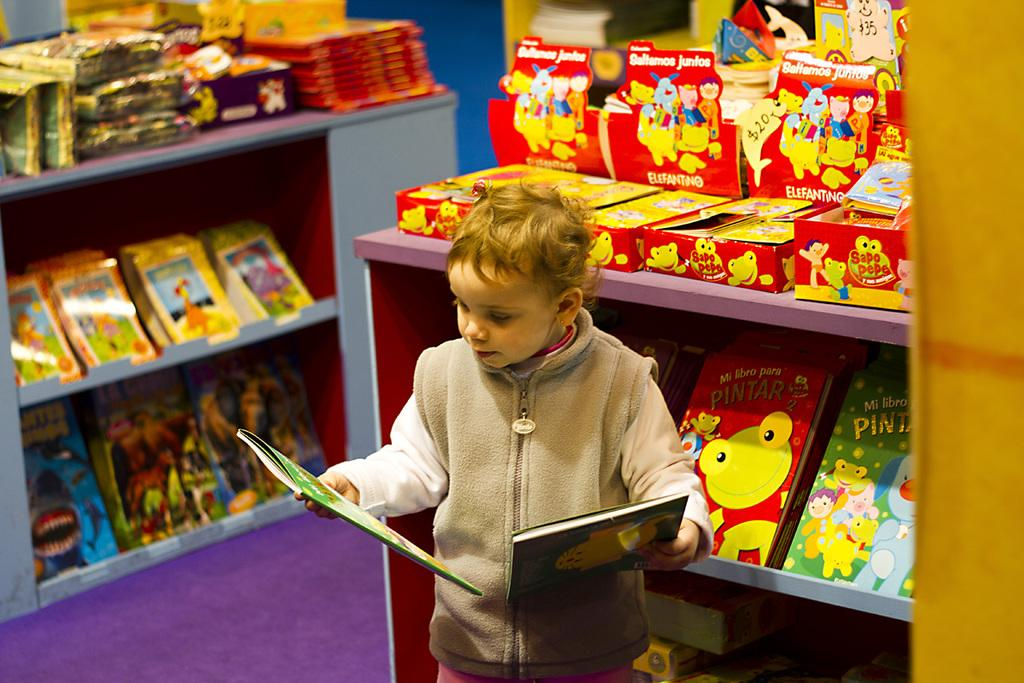<image>
Present a compact description of the photo's key features. A young boy reads a book in front of a display reading santamos juntos. 